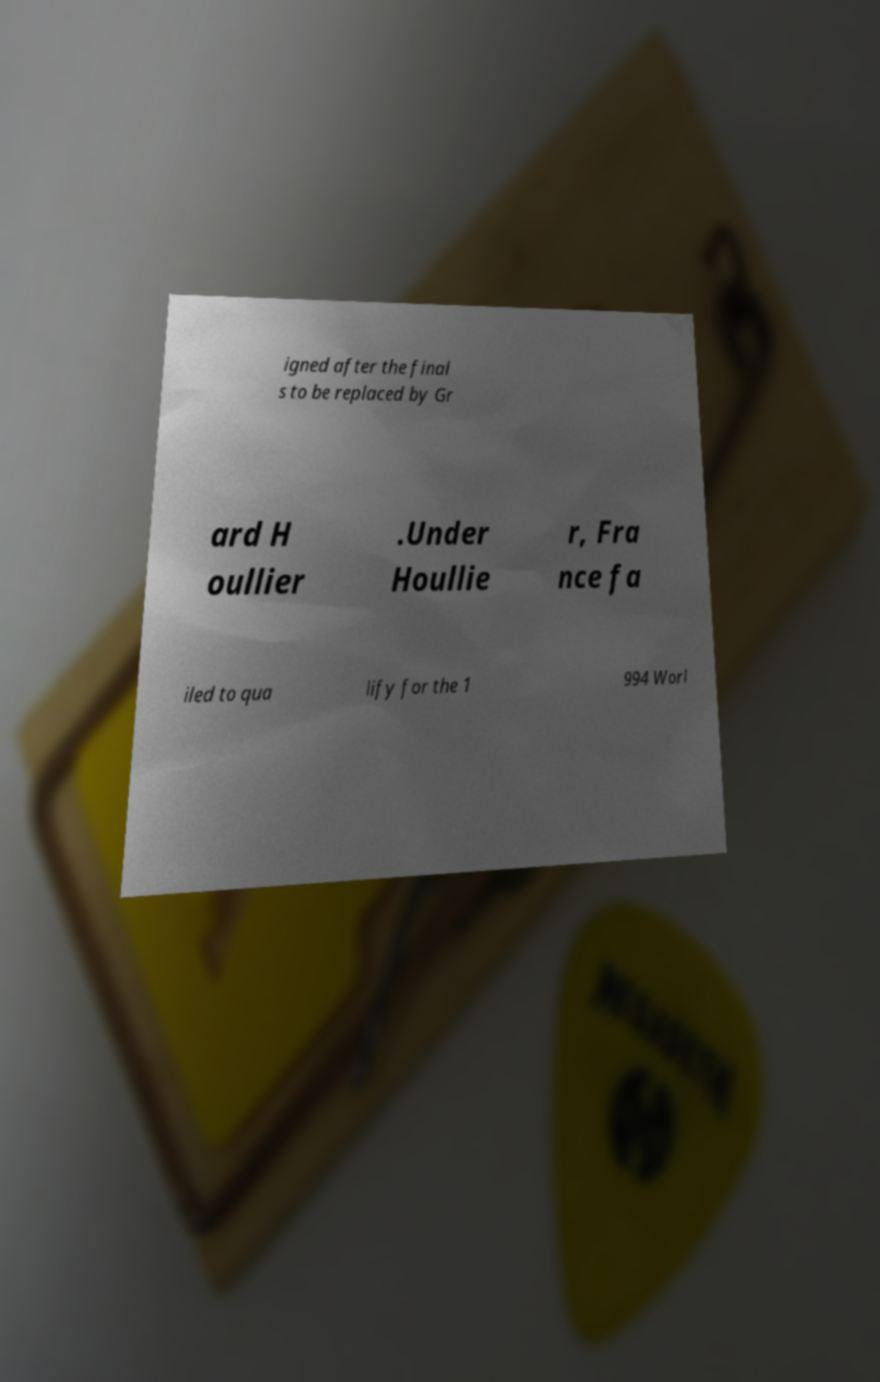Please read and relay the text visible in this image. What does it say? igned after the final s to be replaced by Gr ard H oullier .Under Houllie r, Fra nce fa iled to qua lify for the 1 994 Worl 